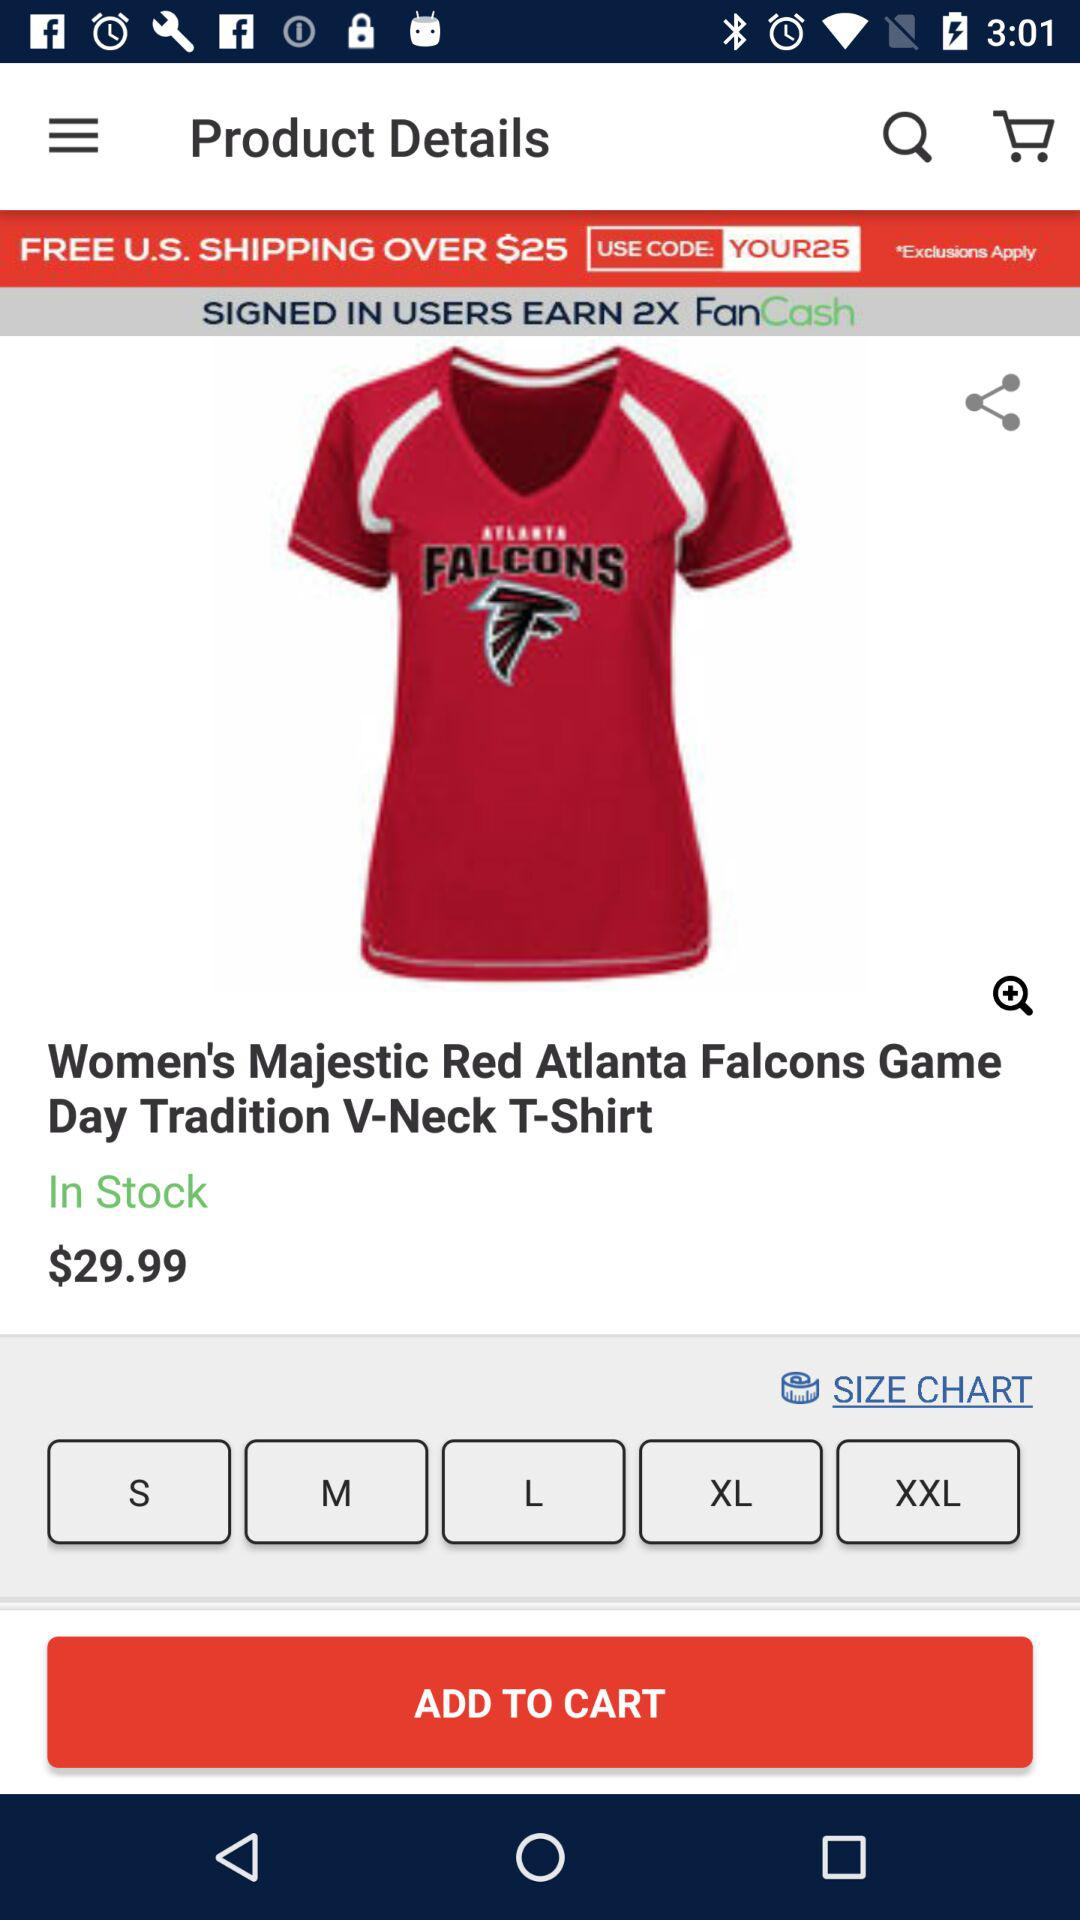How much more is the price of the Atlanta Falcons Game Day Tradition V-Neck T-Shirt than the shipping cost?
Answer the question using a single word or phrase. $29.99 